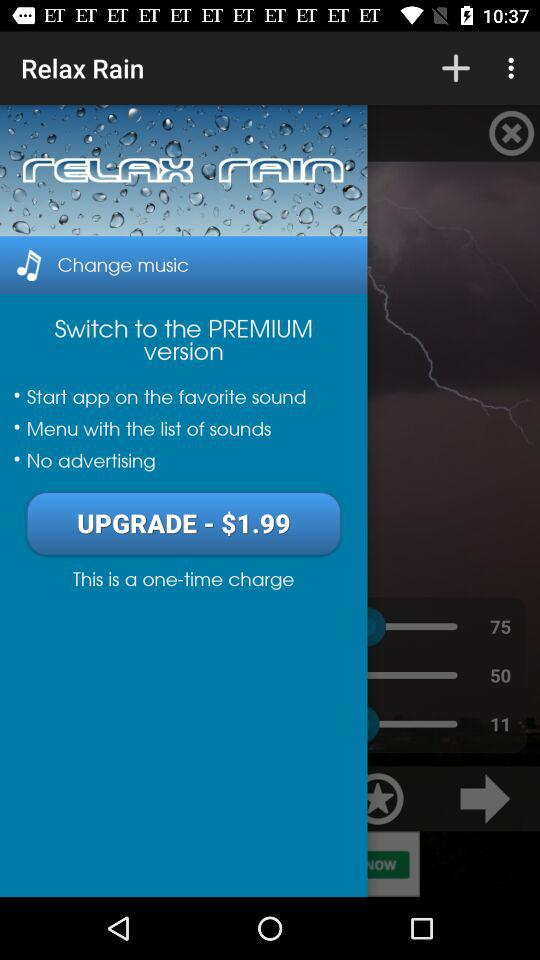How much is the price of the upgrade?
Answer the question using a single word or phrase. $1.99 